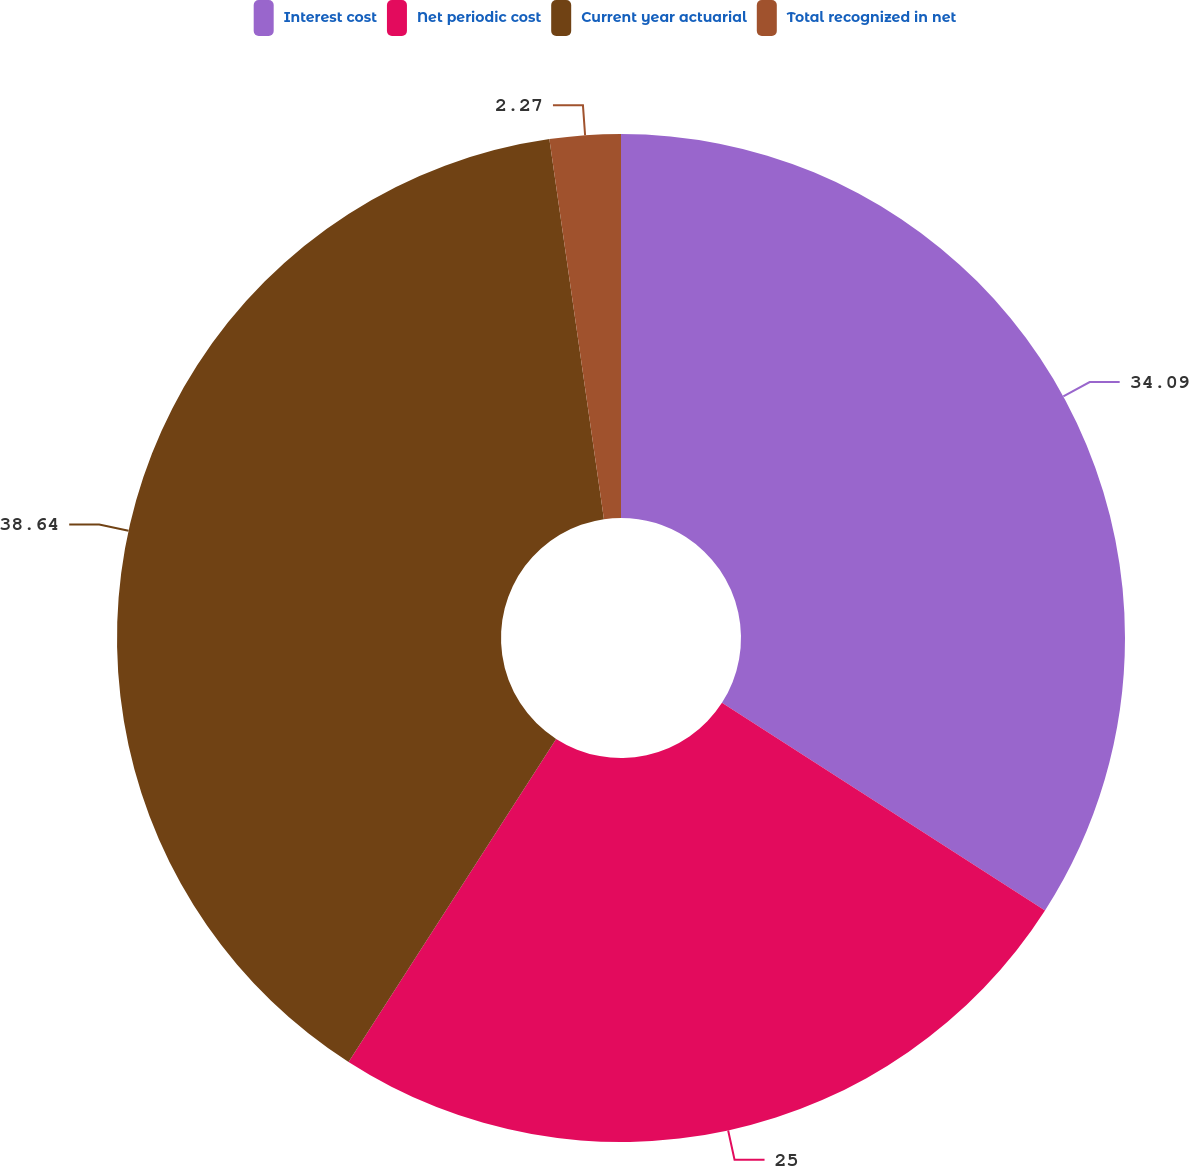Convert chart. <chart><loc_0><loc_0><loc_500><loc_500><pie_chart><fcel>Interest cost<fcel>Net periodic cost<fcel>Current year actuarial<fcel>Total recognized in net<nl><fcel>34.09%<fcel>25.0%<fcel>38.64%<fcel>2.27%<nl></chart> 